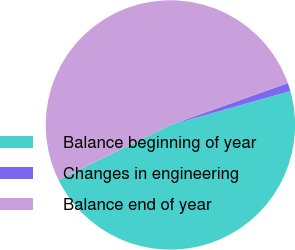<chart> <loc_0><loc_0><loc_500><loc_500><pie_chart><fcel>Balance beginning of year<fcel>Changes in engineering<fcel>Balance end of year<nl><fcel>47.11%<fcel>1.07%<fcel>51.82%<nl></chart> 